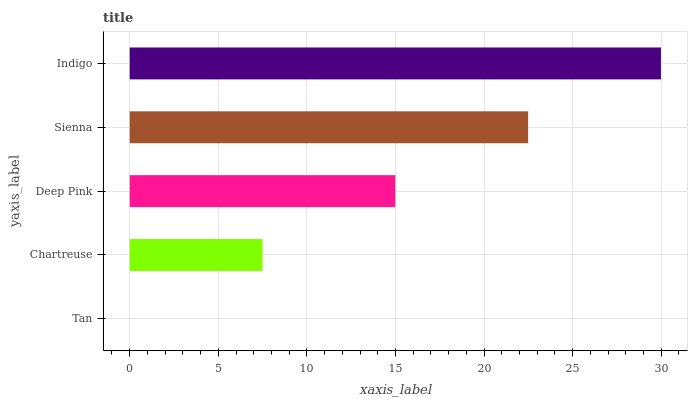Is Tan the minimum?
Answer yes or no. Yes. Is Indigo the maximum?
Answer yes or no. Yes. Is Chartreuse the minimum?
Answer yes or no. No. Is Chartreuse the maximum?
Answer yes or no. No. Is Chartreuse greater than Tan?
Answer yes or no. Yes. Is Tan less than Chartreuse?
Answer yes or no. Yes. Is Tan greater than Chartreuse?
Answer yes or no. No. Is Chartreuse less than Tan?
Answer yes or no. No. Is Deep Pink the high median?
Answer yes or no. Yes. Is Deep Pink the low median?
Answer yes or no. Yes. Is Sienna the high median?
Answer yes or no. No. Is Tan the low median?
Answer yes or no. No. 